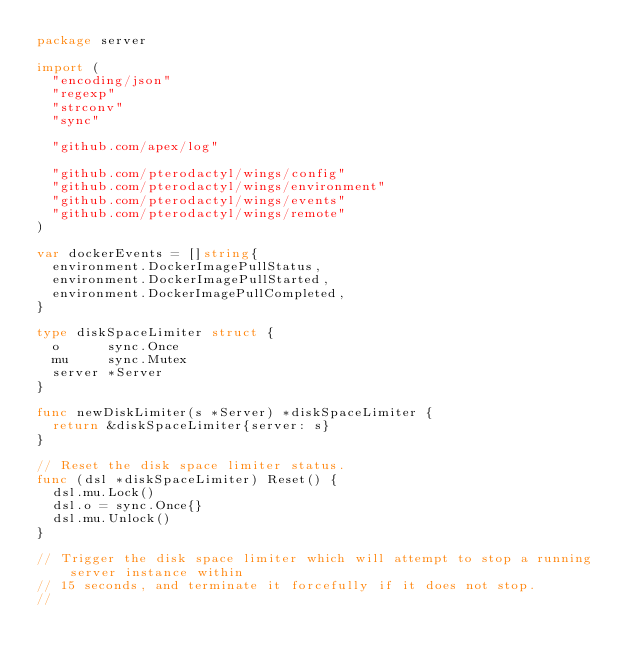<code> <loc_0><loc_0><loc_500><loc_500><_Go_>package server

import (
	"encoding/json"
	"regexp"
	"strconv"
	"sync"

	"github.com/apex/log"

	"github.com/pterodactyl/wings/config"
	"github.com/pterodactyl/wings/environment"
	"github.com/pterodactyl/wings/events"
	"github.com/pterodactyl/wings/remote"
)

var dockerEvents = []string{
	environment.DockerImagePullStatus,
	environment.DockerImagePullStarted,
	environment.DockerImagePullCompleted,
}

type diskSpaceLimiter struct {
	o      sync.Once
	mu     sync.Mutex
	server *Server
}

func newDiskLimiter(s *Server) *diskSpaceLimiter {
	return &diskSpaceLimiter{server: s}
}

// Reset the disk space limiter status.
func (dsl *diskSpaceLimiter) Reset() {
	dsl.mu.Lock()
	dsl.o = sync.Once{}
	dsl.mu.Unlock()
}

// Trigger the disk space limiter which will attempt to stop a running server instance within
// 15 seconds, and terminate it forcefully if it does not stop.
//</code> 